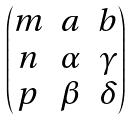<formula> <loc_0><loc_0><loc_500><loc_500>\begin{pmatrix} m & a & b \\ n & \alpha & \gamma \\ p & \beta & \delta \end{pmatrix}</formula> 